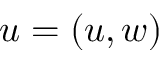Convert formula to latex. <formula><loc_0><loc_0><loc_500><loc_500>u = ( u , w )</formula> 